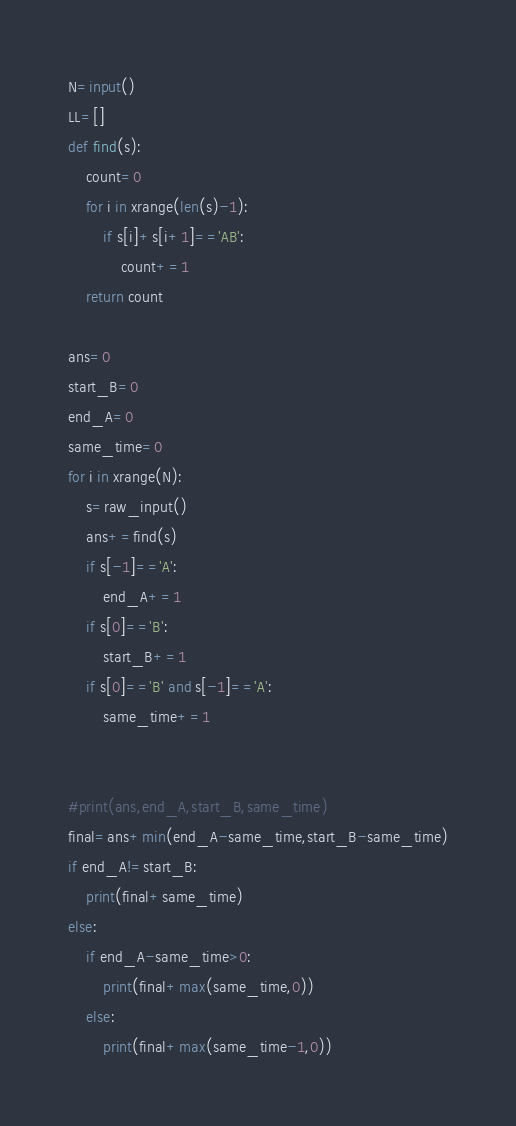<code> <loc_0><loc_0><loc_500><loc_500><_Python_>N=input()
LL=[]
def find(s):
    count=0
    for i in xrange(len(s)-1):
        if s[i]+s[i+1]=='AB':
            count+=1
    return count        
 
ans=0
start_B=0
end_A=0
same_time=0
for i in xrange(N):
    s=raw_input()
    ans+=find(s)
    if s[-1]=='A':
        end_A+=1
    if s[0]=='B':
        start_B+=1   
    if s[0]=='B' and s[-1]=='A':
        same_time+=1
 
 
#print(ans,end_A,start_B,same_time)
final=ans+min(end_A-same_time,start_B-same_time)
if end_A!=start_B:
    print(final+same_time)
else:
    if end_A-same_time>0:
        print(final+max(same_time,0))
    else:
        print(final+max(same_time-1,0))
</code> 